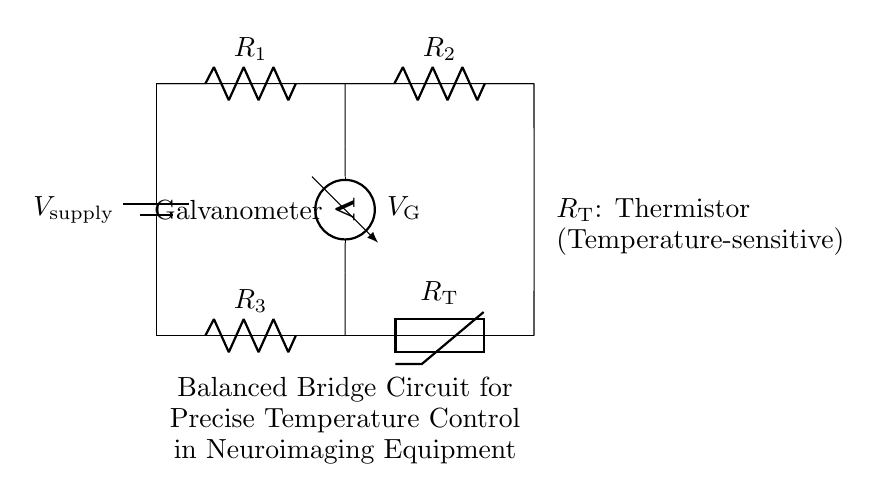What is the power supply voltage in this circuit? The circuit includes a power supply labeled as V_supply, which indicates it provides a specific voltage necessary for operation. However, the voltage value is not directly given in the diagram, so we refer to it simply as V_supply.
Answer: V_supply What type of component is R_T? R_T is specifically marked as a thermistor in the circuit, which means it is a temperature-sensitive resistor that changes its resistance according to temperature changes.
Answer: Thermistor Which two resistors are in series in this circuit? By analyzing the connections, R_1 and R_2 can be seen as connected between the same two nodes at the top of the circuit, indicating they are in series.
Answer: R_1 and R_2 What is the role of the galvanometer in the circuit? The galvanometer is connected between two midpoints of the two resistor branches, and it measures the voltage difference between these points, which helps to detect any imbalance in the bridge circuit.
Answer: Measure voltage difference When is the bridge circuit balanced? The bridge circuit is balanced when the voltage measured by the galvanometer (V_G) reads zero, indicating that the ratio of the resistances in the two branches is equal, thus ensuring precise temperature control by the thermistor.
Answer: When V_G = 0 